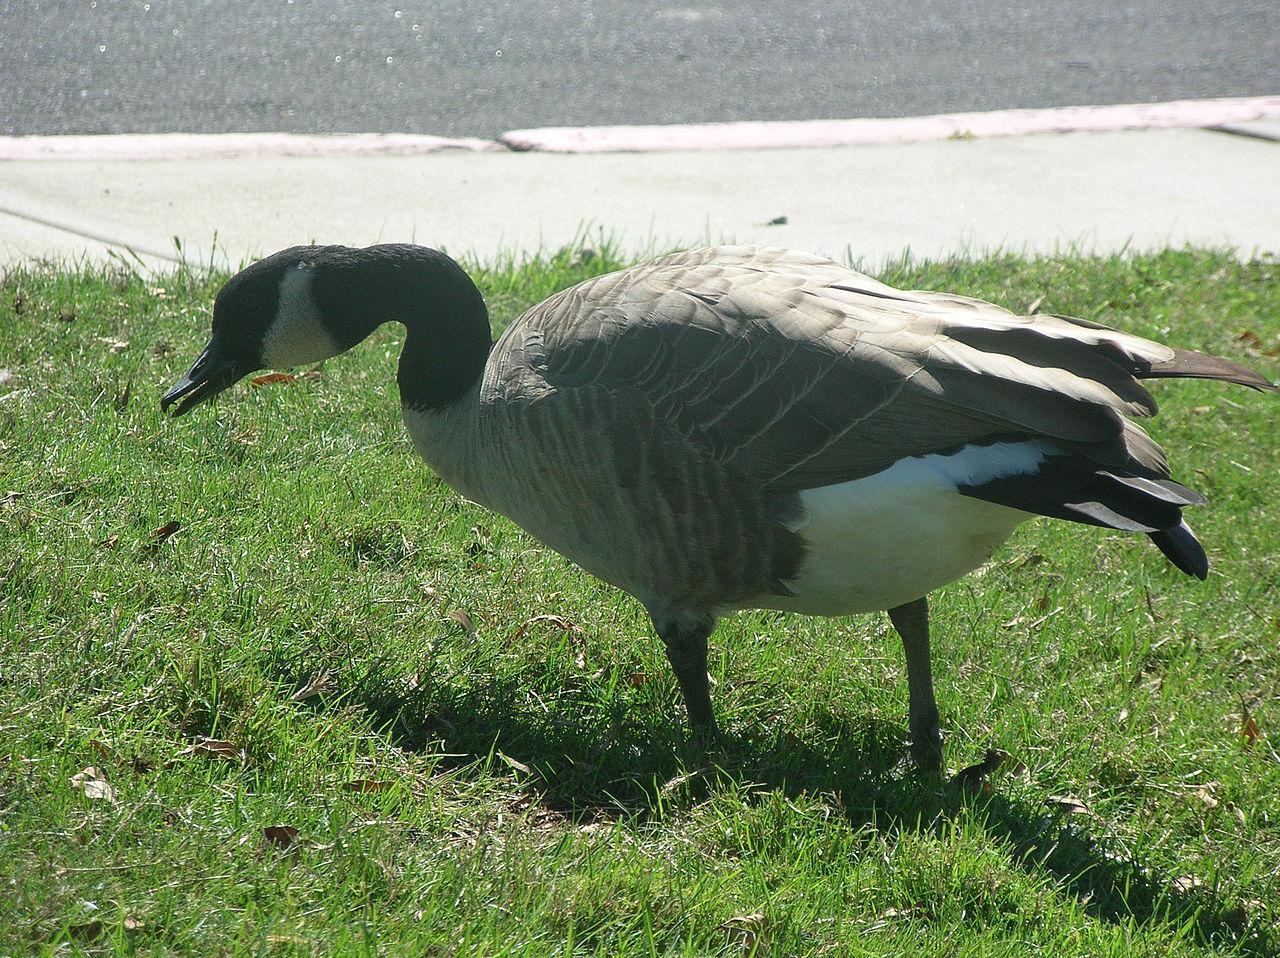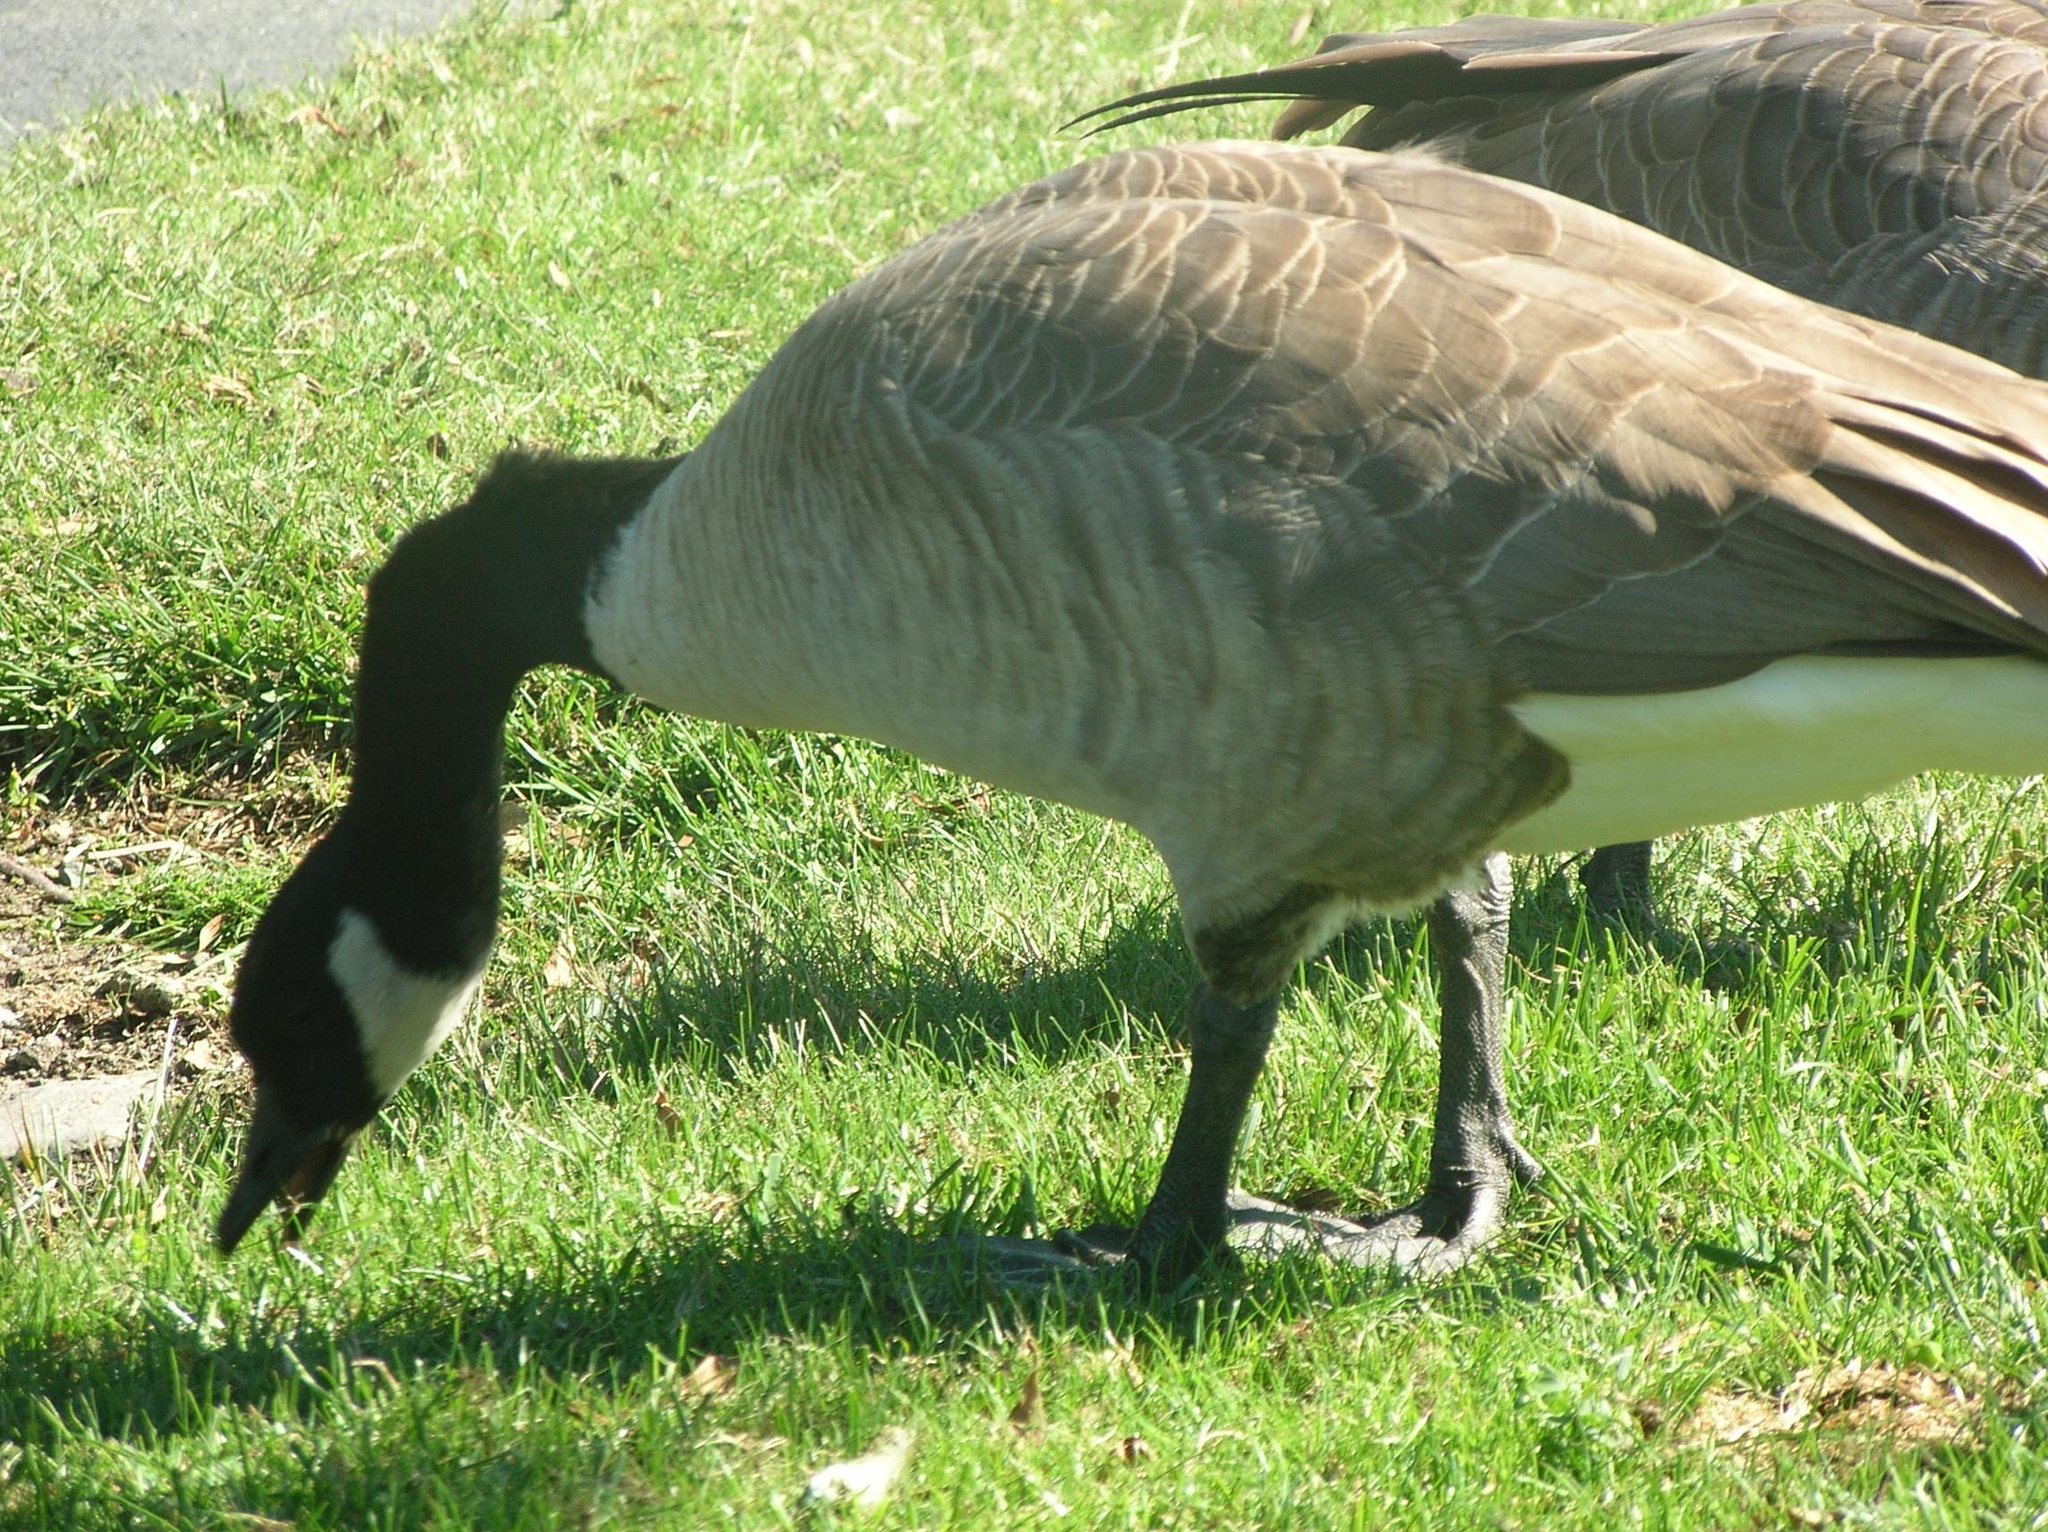The first image is the image on the left, the second image is the image on the right. Assess this claim about the two images: "The right image contains no more than one goose.". Correct or not? Answer yes or no. No. The first image is the image on the left, the second image is the image on the right. For the images shown, is this caption "No image contains more than two geese, and all geese are standing in grassy areas." true? Answer yes or no. Yes. 